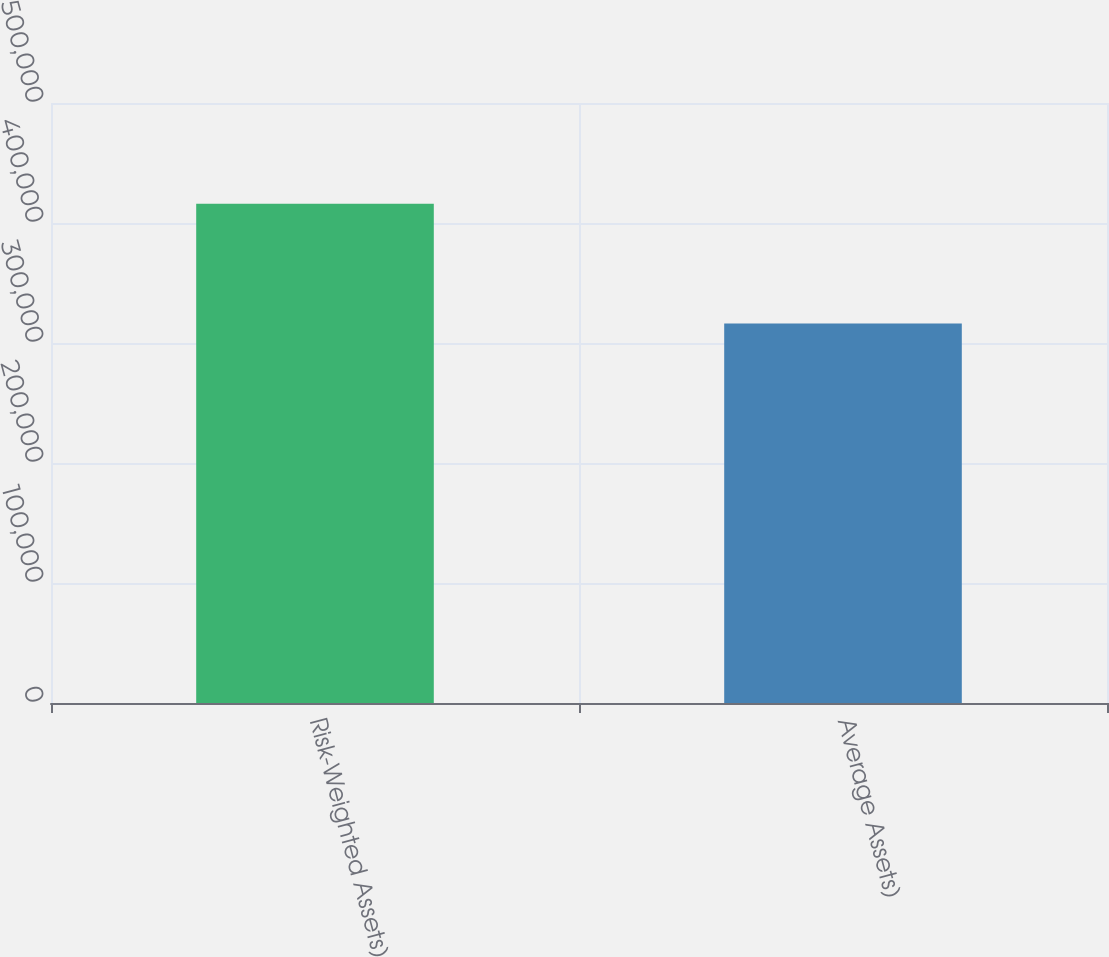Convert chart to OTSL. <chart><loc_0><loc_0><loc_500><loc_500><bar_chart><fcel>Risk-Weighted Assets)<fcel>Average Assets)<nl><fcel>416040<fcel>316309<nl></chart> 